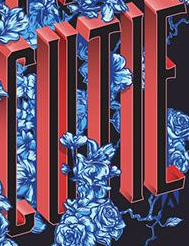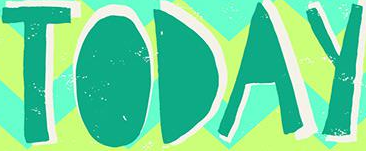What text is displayed in these images sequentially, separated by a semicolon? CUTIE; TODAY 